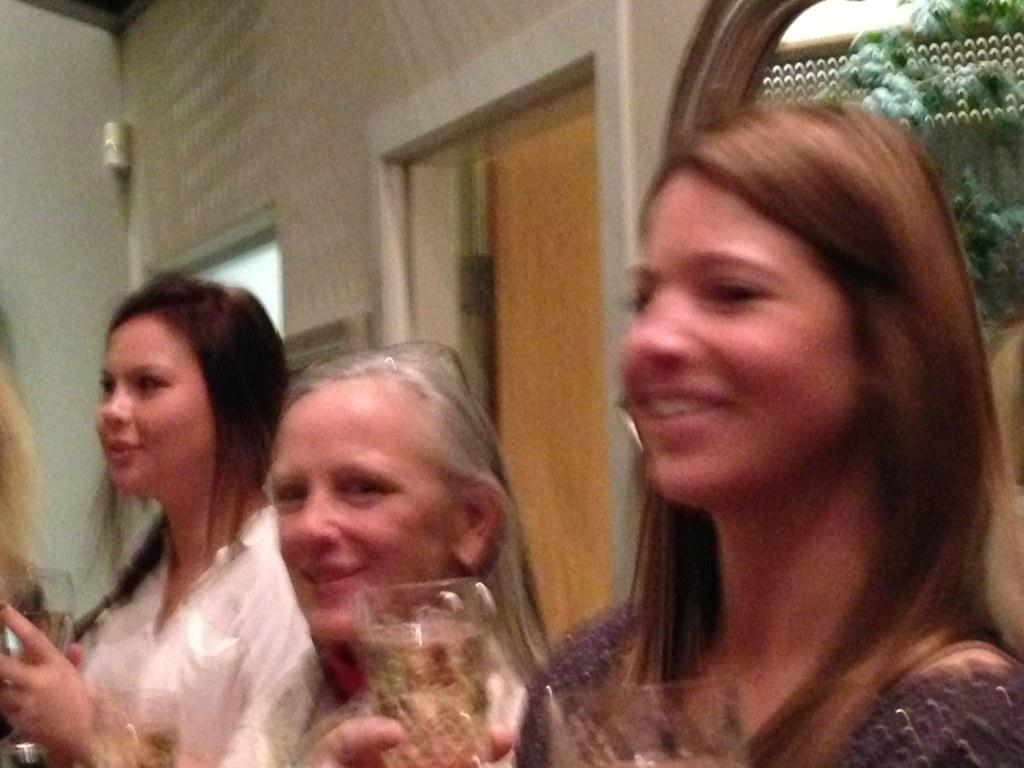How many people are in the image? There are three people in the image. What is one person doing with their hands? One person is holding a glass. How does the person holding the glass appear to feel? The person holding the glass is smiling. What can be seen behind the people in the image? There is a wall visible in the image. What object is visible in the image that is also being held by one of the people? There is a glass visible in the image. What type of horn can be heard in the image? There is no horn present in the image, and therefore no sound can be heard. What is the opinion of the person holding the glass about the current situation? The image does not provide any information about the person's opinion, as it only shows their smile and not their thoughts or feelings. 